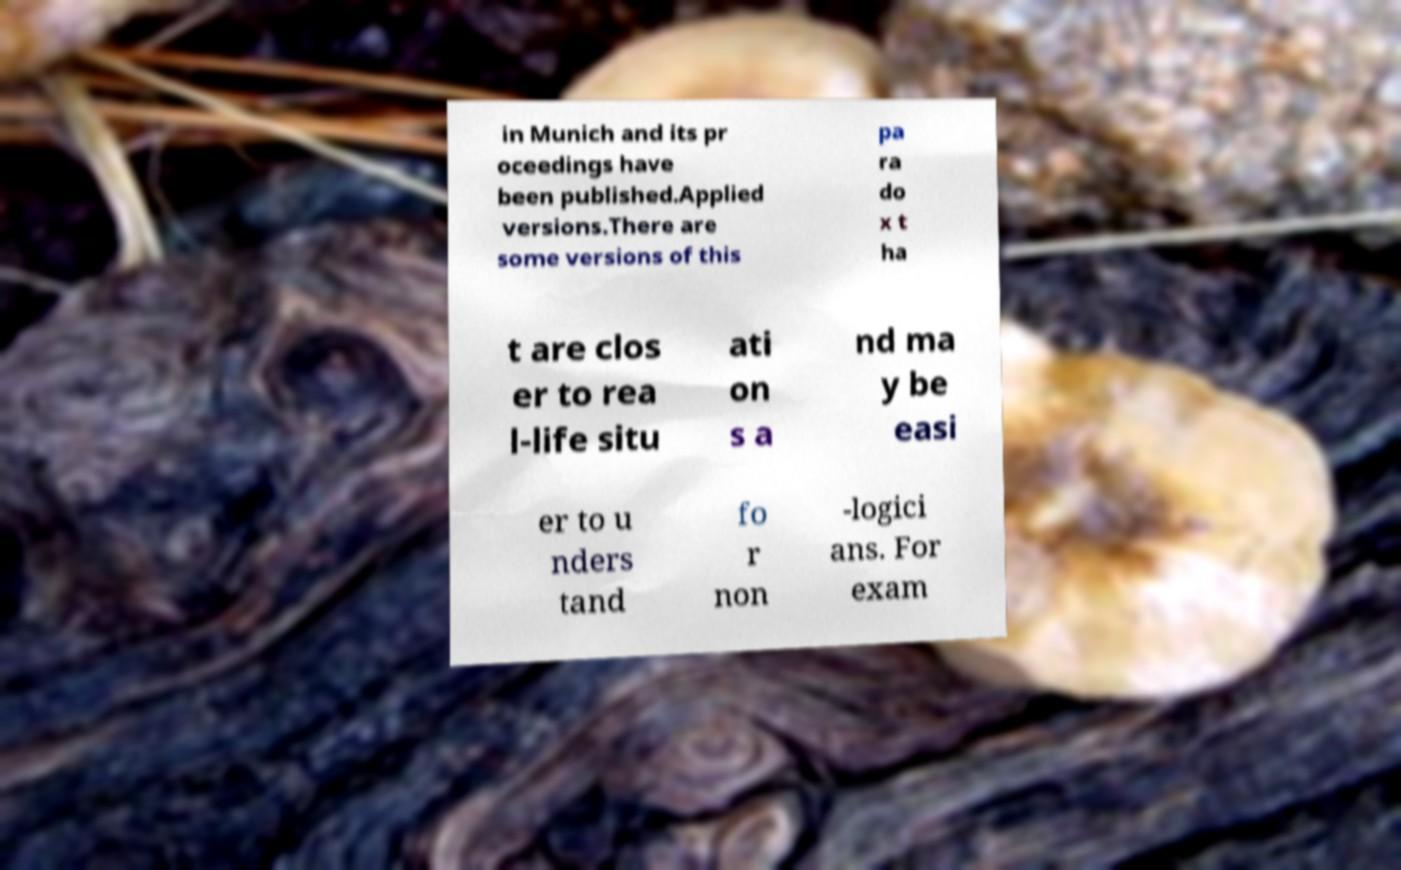Can you read and provide the text displayed in the image?This photo seems to have some interesting text. Can you extract and type it out for me? in Munich and its pr oceedings have been published.Applied versions.There are some versions of this pa ra do x t ha t are clos er to rea l-life situ ati on s a nd ma y be easi er to u nders tand fo r non -logici ans. For exam 